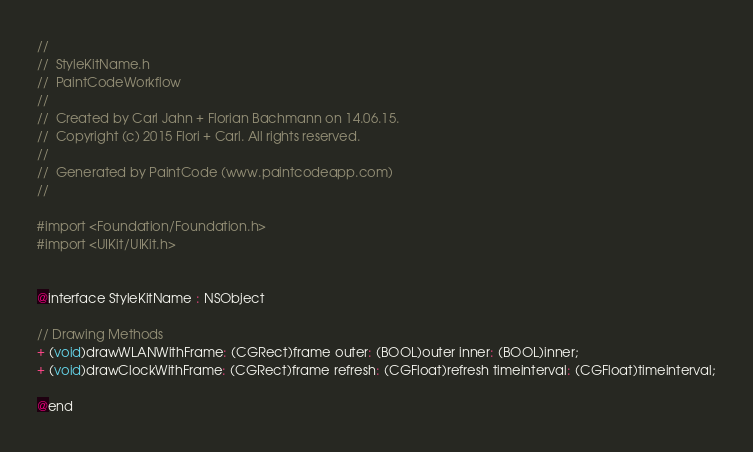<code> <loc_0><loc_0><loc_500><loc_500><_C_>//
//  StyleKitName.h
//  PaintCodeWorkflow
//
//  Created by Carl Jahn + Florian Bachmann on 14.06.15.
//  Copyright (c) 2015 Flori + Carl. All rights reserved.
//
//  Generated by PaintCode (www.paintcodeapp.com)
//

#import <Foundation/Foundation.h>
#import <UIKit/UIKit.h>


@interface StyleKitName : NSObject

// Drawing Methods
+ (void)drawWLANWithFrame: (CGRect)frame outer: (BOOL)outer inner: (BOOL)inner;
+ (void)drawClockWithFrame: (CGRect)frame refresh: (CGFloat)refresh timeinterval: (CGFloat)timeinterval;

@end
</code> 